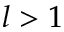<formula> <loc_0><loc_0><loc_500><loc_500>l > 1</formula> 